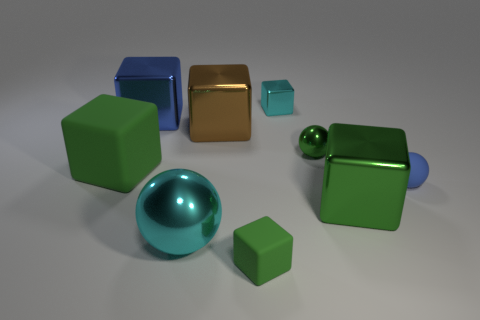What number of metal balls are right of the rubber object behind the blue thing that is in front of the tiny green metallic sphere?
Make the answer very short. 2. There is a tiny green object that is the same material as the cyan ball; what shape is it?
Your answer should be very brief. Sphere. There is a tiny thing in front of the large green cube that is in front of the big green object that is left of the tiny green matte block; what is its material?
Your response must be concise. Rubber. How many objects are green matte things in front of the large matte cube or purple blocks?
Make the answer very short. 1. How many other things are there of the same shape as the big brown metal object?
Keep it short and to the point. 5. Are there more large metallic blocks on the right side of the small blue thing than blue matte spheres?
Your answer should be compact. No. There is a green thing that is the same shape as the blue rubber thing; what size is it?
Your answer should be very brief. Small. Are there any other things that have the same material as the green ball?
Offer a terse response. Yes. What is the shape of the brown metallic object?
Your response must be concise. Cube. What shape is the green rubber object that is the same size as the cyan metallic cube?
Offer a terse response. Cube. 